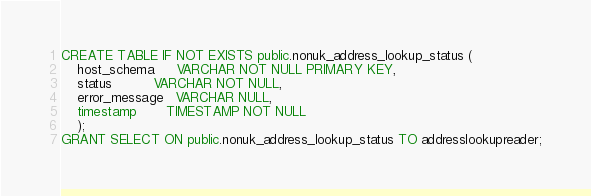Convert code to text. <code><loc_0><loc_0><loc_500><loc_500><_SQL_>CREATE TABLE IF NOT EXISTS public.nonuk_address_lookup_status (
    host_schema     VARCHAR NOT NULL PRIMARY KEY,
    status          VARCHAR NOT NULL,
    error_message   VARCHAR NULL,
    timestamp       TIMESTAMP NOT NULL
    );
GRANT SELECT ON public.nonuk_address_lookup_status TO addresslookupreader;
</code> 